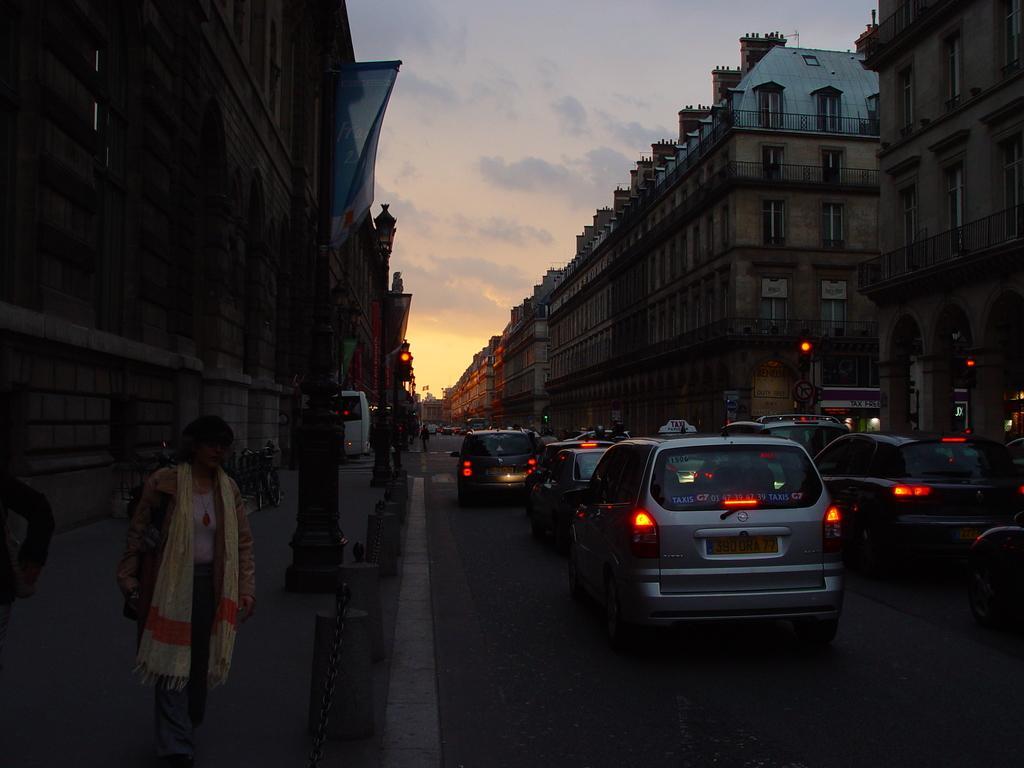In one or two sentences, can you explain what this image depicts? In the bottom right corner of the image there are some vehicles on the road. In the bottom left corner of the image few people are standing. Behind them there are some poles, bicycles and buildings. At the top of the image there are some clouds in the sky. 